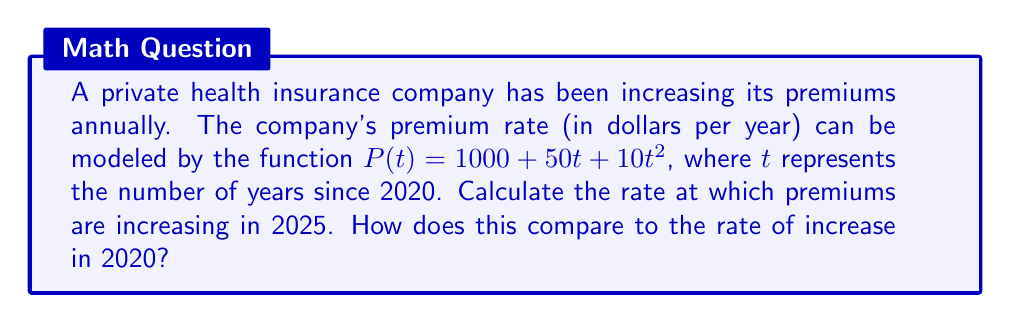Solve this math problem. To solve this problem, we need to find the rate of change of the premium function at two different points in time. This can be done using the derivative of the function.

1. First, let's find the derivative of $P(t)$:
   $$P'(t) = \frac{d}{dt}(1000 + 50t + 10t^2) = 50 + 20t$$

2. The rate of increase in 2025:
   In 2025, $t = 5$ (5 years after 2020)
   $$P'(5) = 50 + 20(5) = 50 + 100 = 150$$

3. The rate of increase in 2020:
   In 2020, $t = 0$
   $$P'(0) = 50 + 20(0) = 50$$

4. Comparison:
   The rate of increase in 2025 ($150 per year) is three times the rate of increase in 2020 ($50 per year).

This accelerating rate of increase demonstrates how private insurance companies may be rapidly escalating their premiums over time, potentially making health coverage increasingly unaffordable for consumers.
Answer: The rate of premium increase in 2025 is $150 per year, which is three times the rate of $50 per year in 2020. 